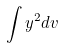Convert formula to latex. <formula><loc_0><loc_0><loc_500><loc_500>\int y ^ { 2 } d v</formula> 